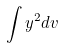Convert formula to latex. <formula><loc_0><loc_0><loc_500><loc_500>\int y ^ { 2 } d v</formula> 